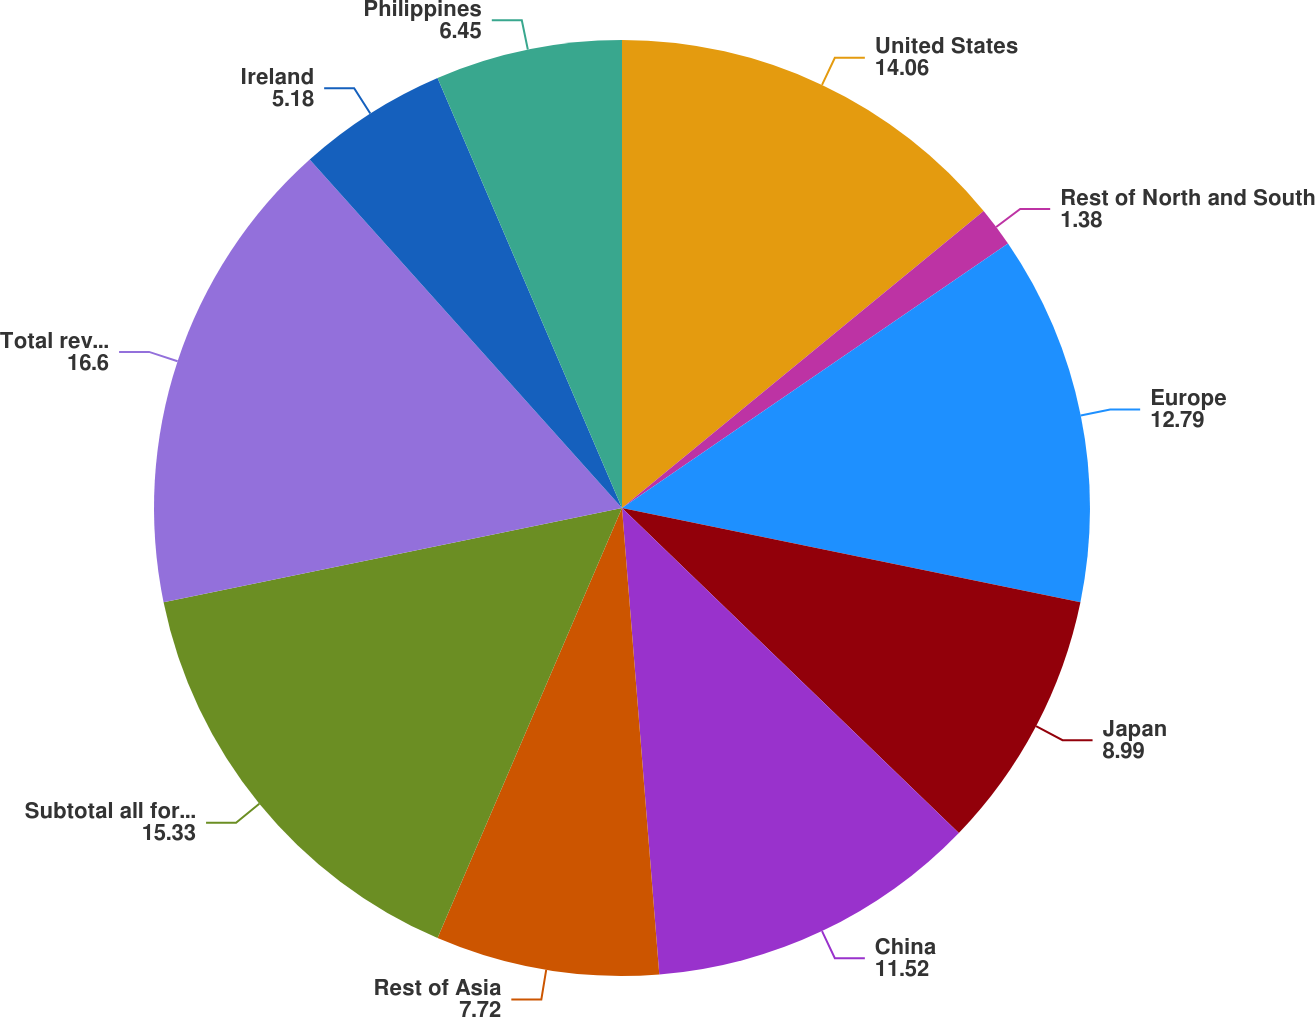Convert chart. <chart><loc_0><loc_0><loc_500><loc_500><pie_chart><fcel>United States<fcel>Rest of North and South<fcel>Europe<fcel>Japan<fcel>China<fcel>Rest of Asia<fcel>Subtotal all foreign countries<fcel>Total revenue<fcel>Ireland<fcel>Philippines<nl><fcel>14.06%<fcel>1.38%<fcel>12.79%<fcel>8.99%<fcel>11.52%<fcel>7.72%<fcel>15.33%<fcel>16.6%<fcel>5.18%<fcel>6.45%<nl></chart> 